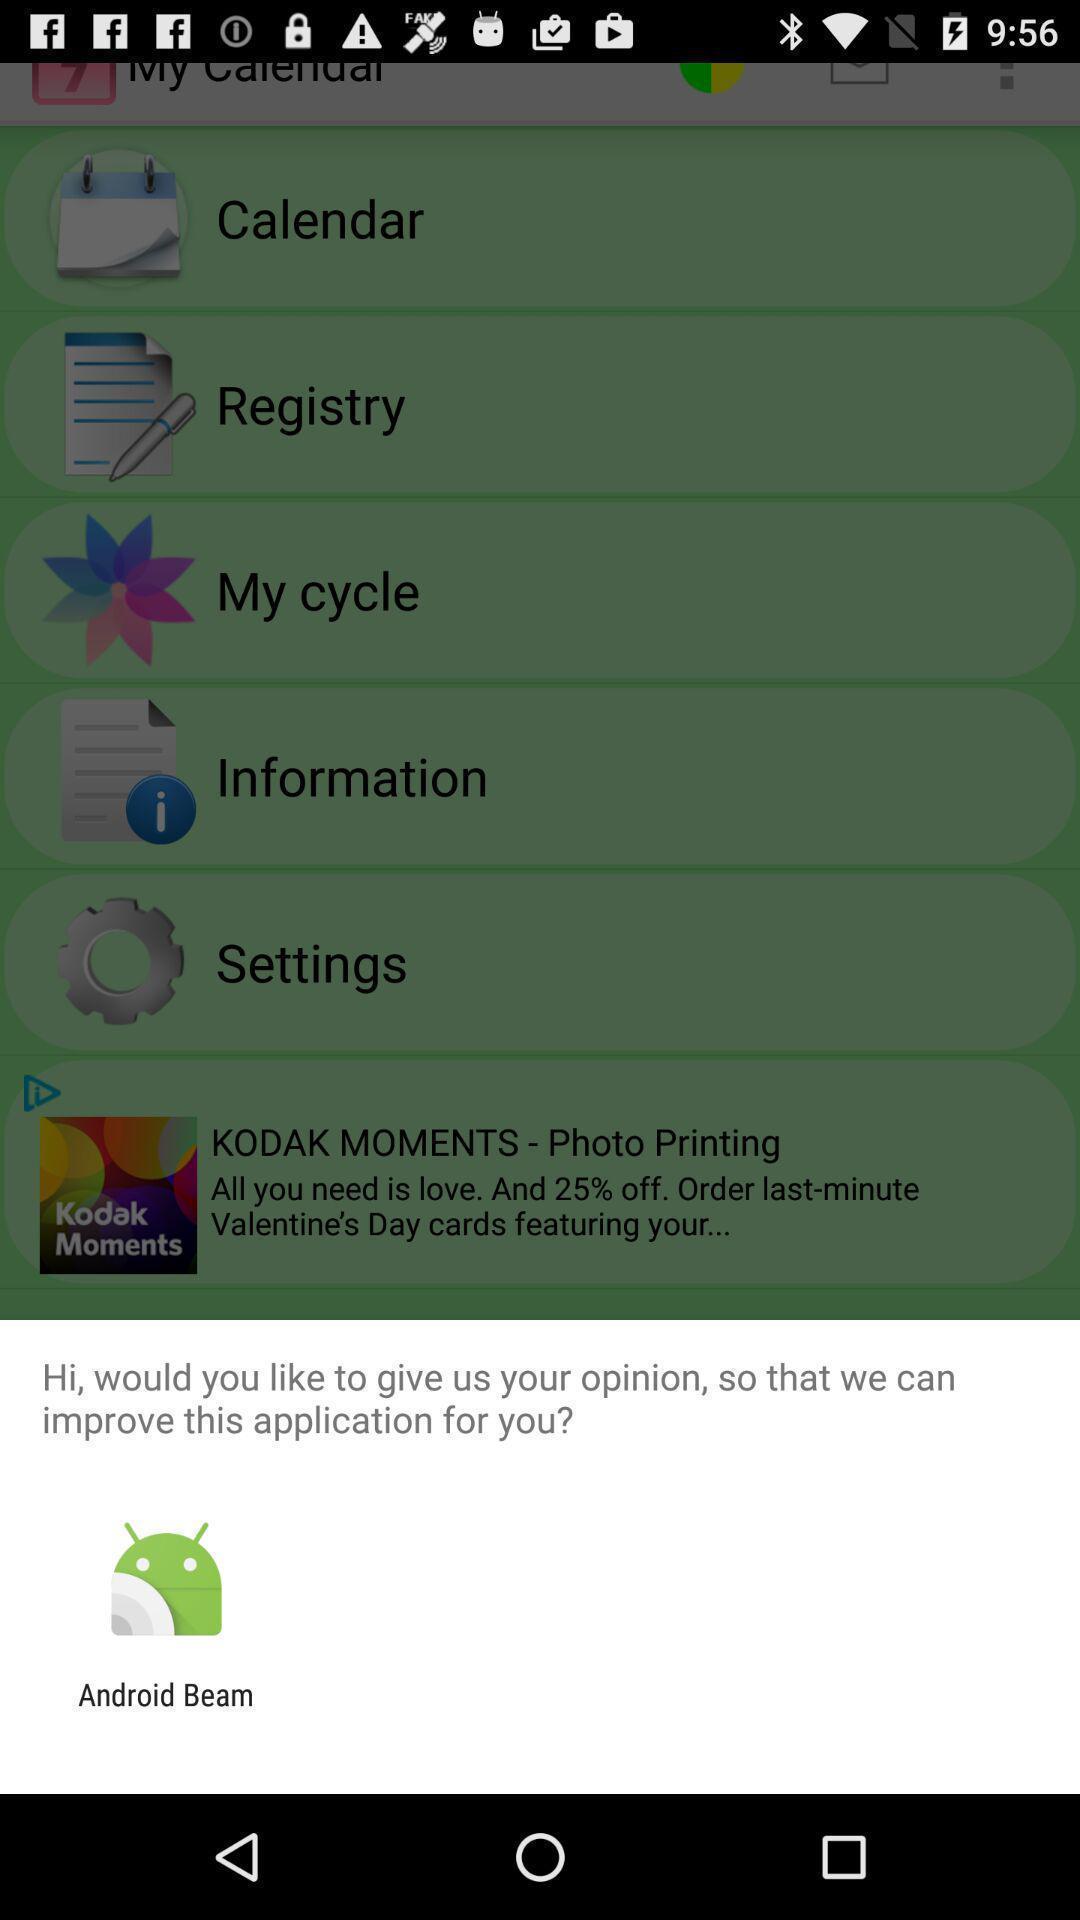What details can you identify in this image? Window asking a feedback to improve app. 